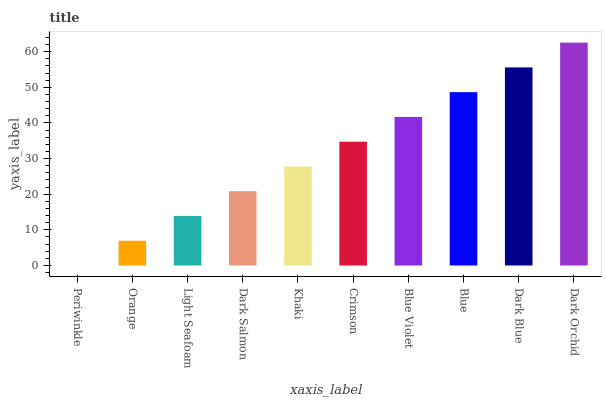Is Periwinkle the minimum?
Answer yes or no. Yes. Is Dark Orchid the maximum?
Answer yes or no. Yes. Is Orange the minimum?
Answer yes or no. No. Is Orange the maximum?
Answer yes or no. No. Is Orange greater than Periwinkle?
Answer yes or no. Yes. Is Periwinkle less than Orange?
Answer yes or no. Yes. Is Periwinkle greater than Orange?
Answer yes or no. No. Is Orange less than Periwinkle?
Answer yes or no. No. Is Crimson the high median?
Answer yes or no. Yes. Is Khaki the low median?
Answer yes or no. Yes. Is Blue Violet the high median?
Answer yes or no. No. Is Dark Salmon the low median?
Answer yes or no. No. 